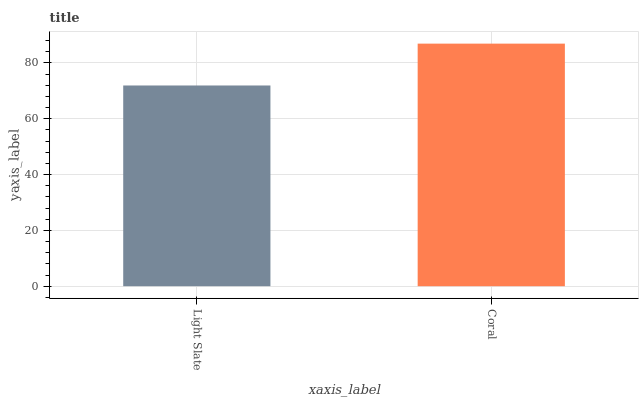Is Light Slate the minimum?
Answer yes or no. Yes. Is Coral the maximum?
Answer yes or no. Yes. Is Coral the minimum?
Answer yes or no. No. Is Coral greater than Light Slate?
Answer yes or no. Yes. Is Light Slate less than Coral?
Answer yes or no. Yes. Is Light Slate greater than Coral?
Answer yes or no. No. Is Coral less than Light Slate?
Answer yes or no. No. Is Coral the high median?
Answer yes or no. Yes. Is Light Slate the low median?
Answer yes or no. Yes. Is Light Slate the high median?
Answer yes or no. No. Is Coral the low median?
Answer yes or no. No. 